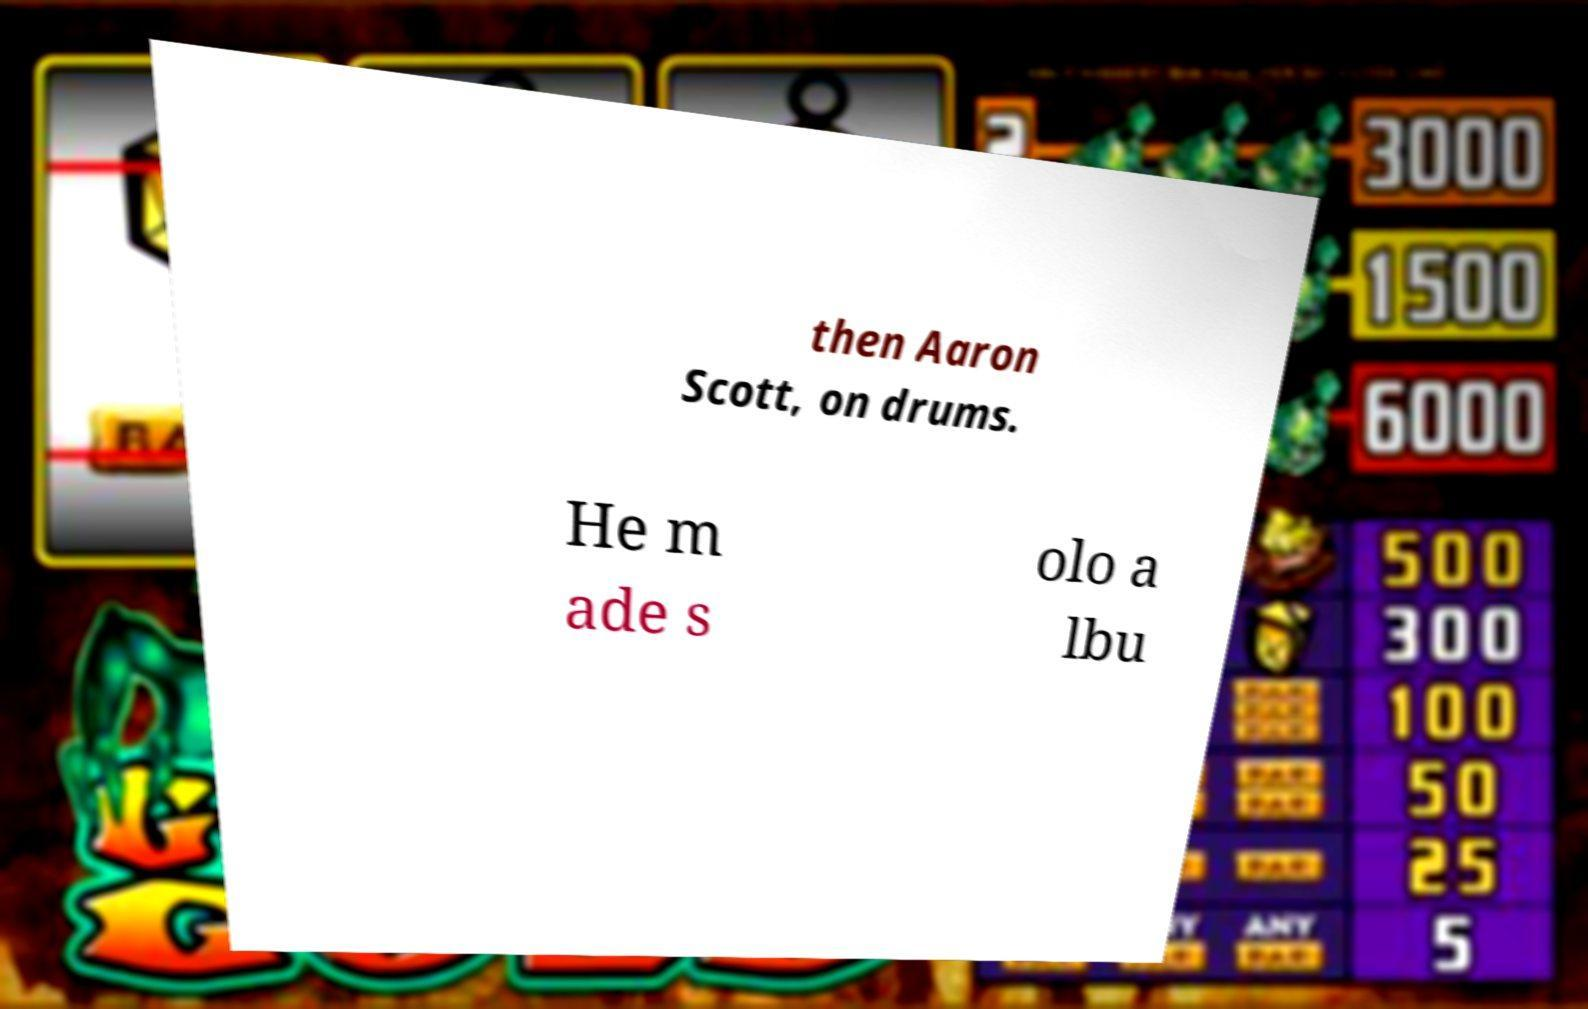Could you extract and type out the text from this image? then Aaron Scott, on drums. He m ade s olo a lbu 